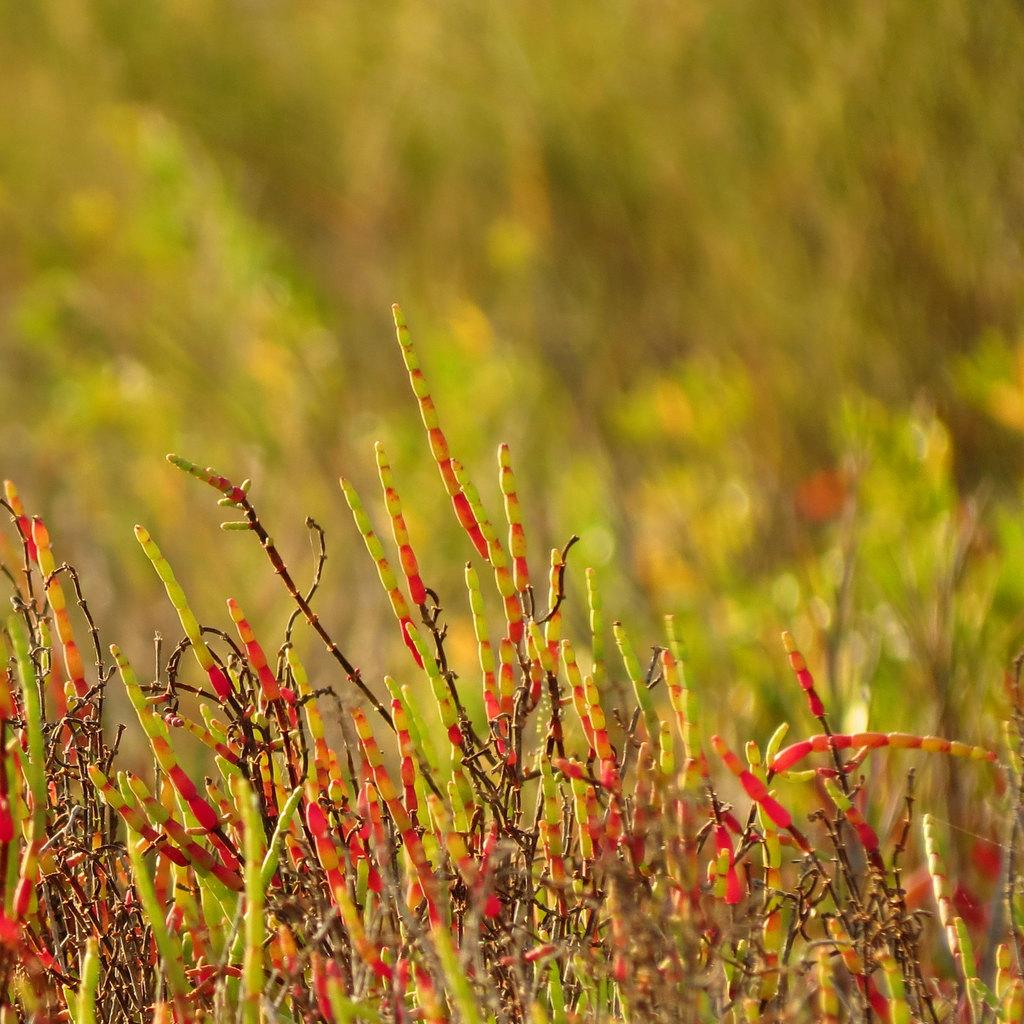What celestial bodies are depicted in the image? There are planets in the image. Can you describe the background of the image? The background of the image is blurry. What type of band is playing in the background of the image? There is no band present in the image; it features planets against a blurry background. Can you tell me how many bits of information are being transmitted in the image? There is no indication of any data transmission in the image, as it only contains planets and a blurry background. 